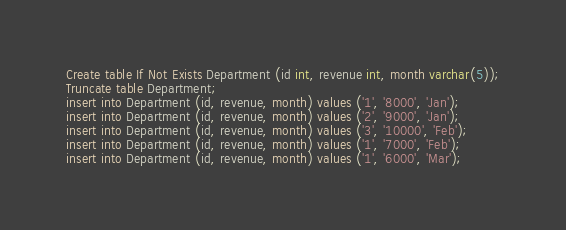Convert code to text. <code><loc_0><loc_0><loc_500><loc_500><_SQL_>Create table If Not Exists Department (id int, revenue int, month varchar(5));
Truncate table Department;
insert into Department (id, revenue, month) values ('1', '8000', 'Jan');
insert into Department (id, revenue, month) values ('2', '9000', 'Jan');
insert into Department (id, revenue, month) values ('3', '10000', 'Feb');
insert into Department (id, revenue, month) values ('1', '7000', 'Feb');
insert into Department (id, revenue, month) values ('1', '6000', 'Mar');
</code> 